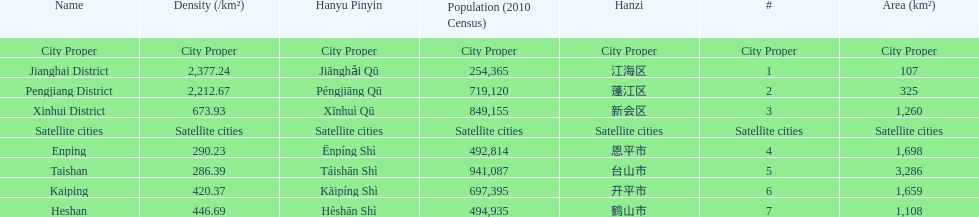What city proper has the smallest area in km2? Jianghai District. 